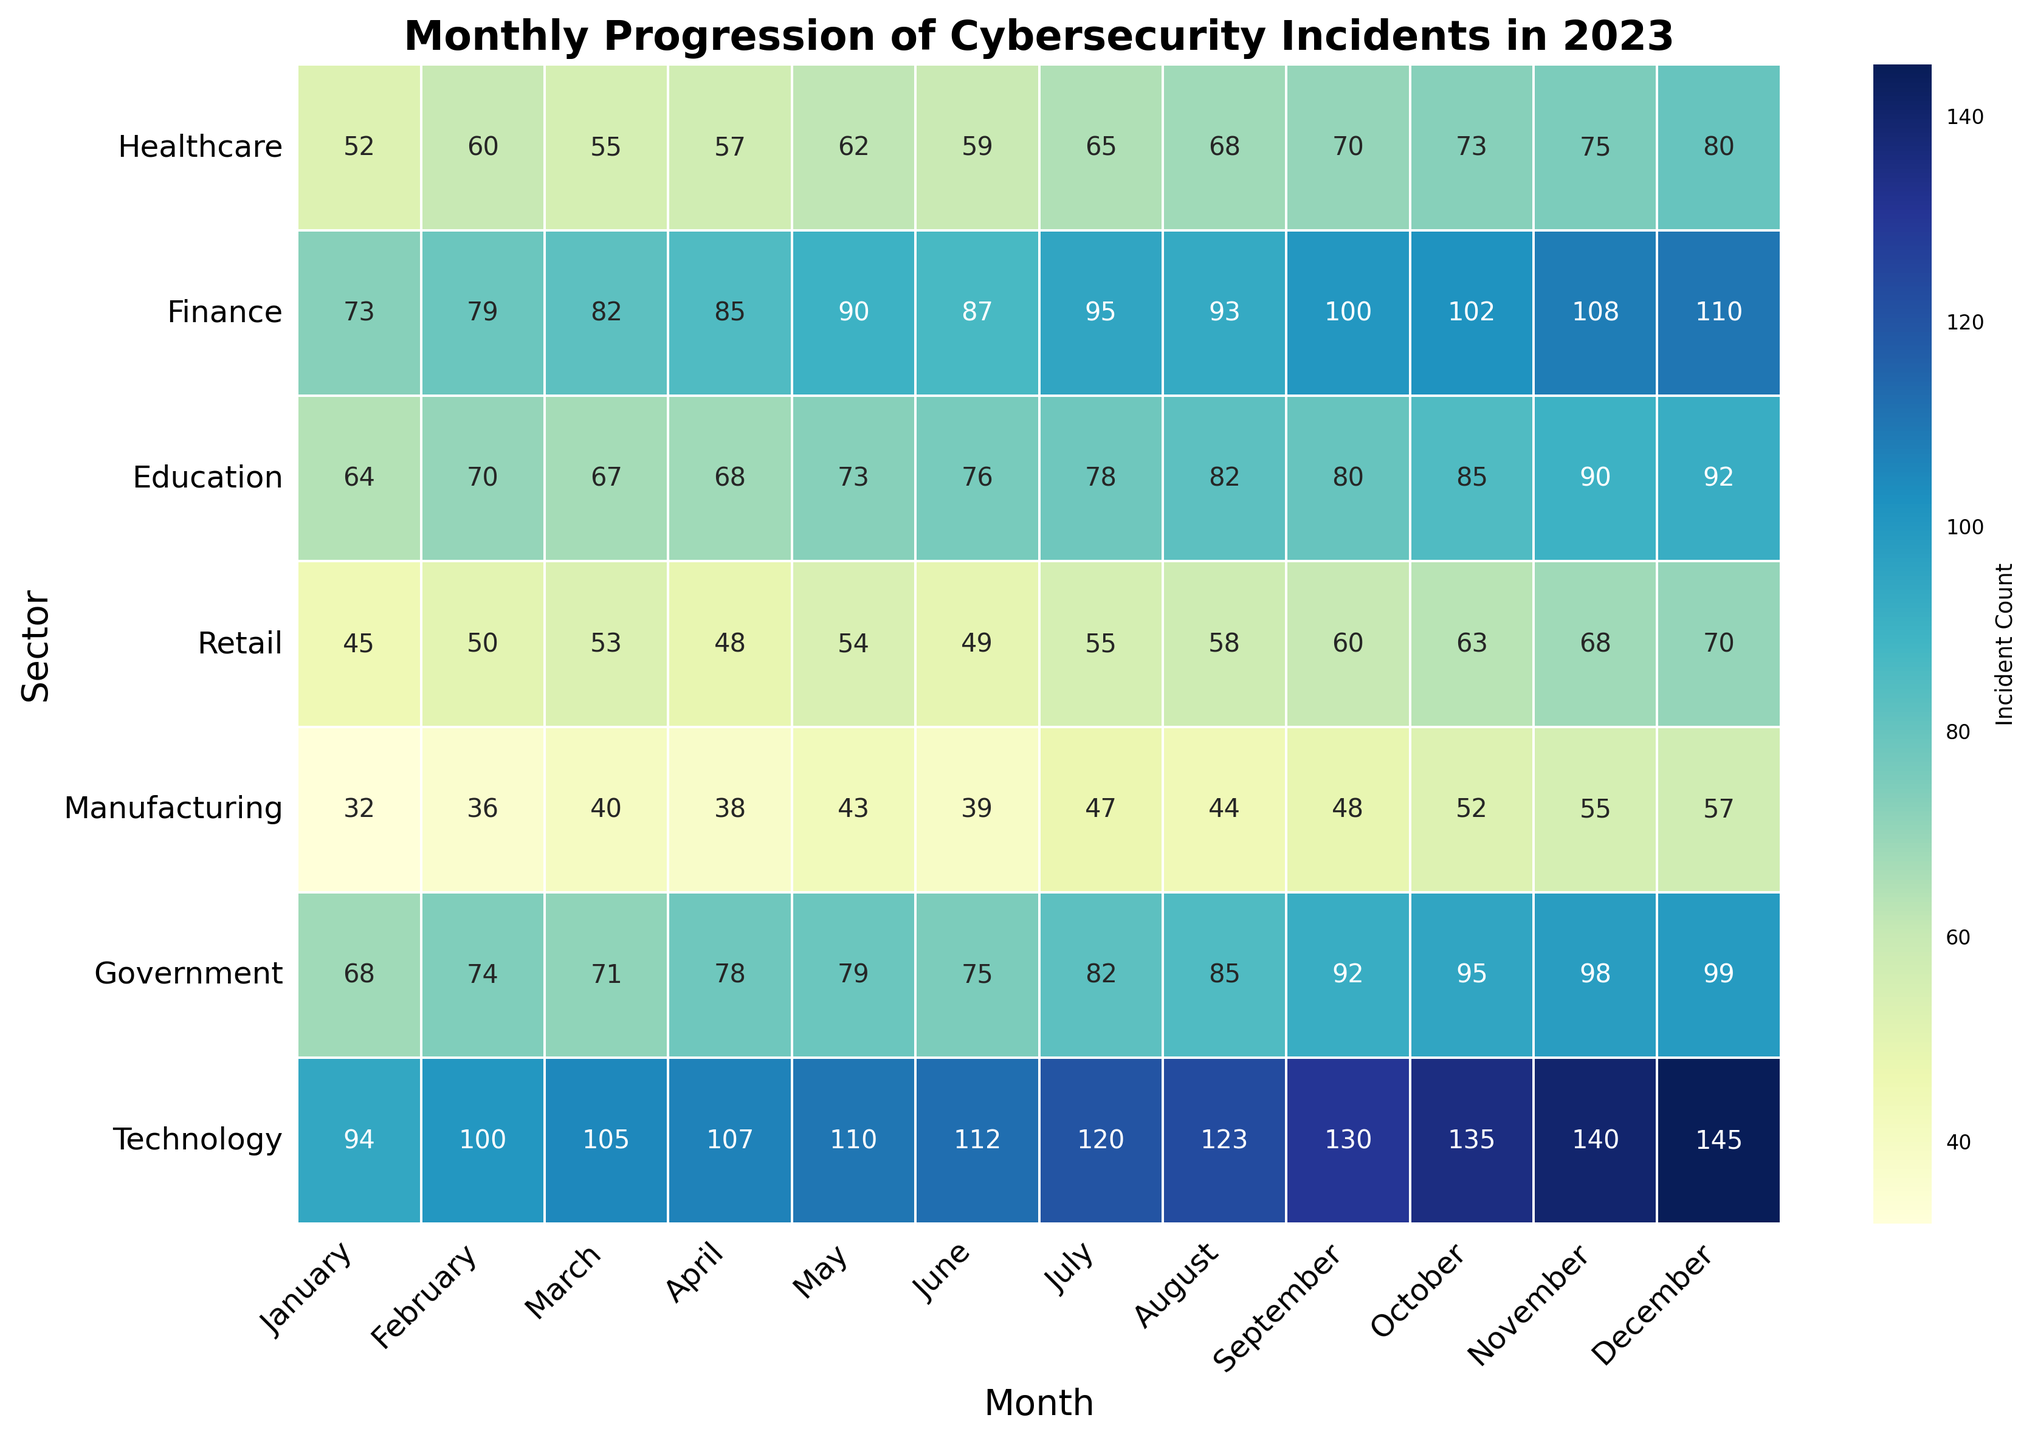Which sector experienced the highest number of cybersecurity incidents in December? By observing the heatmap, identify the sector with the darkest shade for December, indicating the highest number of incidents. The Technology sector shows the darkest shade.
Answer: Technology How many cybersecurity incidents in total did the Finance sector report in April and August combined? Locate the Finance row on the heatmap and find the values for April and August. April has 85 incidents, and August has 93 incidents. Summing them gives 85 + 93 = 178.
Answer: 178 Between Healthcare and Manufacturing, which sector experienced fewer incidents in October, and by how many incidents is it fewer? Compare the values in October for Healthcare and Manufacturing. Healthcare has 73 incidents, and Manufacturing has 52 incidents. The difference is 73 - 52 = 21.
Answer: Manufacturing, by 21 incidents Which month showed the greatest increase in cybersecurity incidents for the Technology sector compared to the previous month? Compare consecutive monthly values in the Technology row and identify the largest increase. The greatest increase is from August (123) to September (130), an increase of 130 - 123 = 7 incidents.
Answer: September Which two sectors showed exactly the same number of incidents in any month(s) during 2023? Scan through the heatmap to identify any matching values across different sectors for the same month. Healthcare and Manufacturing both reported 32 incidents in January.
Answer: Healthcare and Manufacturing in January What is the average number of cybersecurity incidents reported by the Government sector from January to June inclusive? Find the Government values from January to June: 68, 74, 71, 78, 79, 75. Sum these values, 68 + 74 + 71 + 78 + 79 + 75 = 445, and divide by the number of months (6). The average is 445 / 6 ≈ 74.17.
Answer: 74.17 Which sector showed the least variability in the number of monthly incidents throughout the year? Determine which sector's row values are most consistent (smallest range). Retail values range from 45 to 70, so its variability is less compared to other sectors. The Retail sector shows the least variability within 2023.
Answer: Retail Is there a month where every sector reported an increase in incidents compared to the previous month? Check each column (month) to see if all values are higher than the previous month's column. August compared to July shows an increase in every sector: Healthcare (65 to 68), Finance (95 to 93), Education (78 to 82), Retail (55 to 58), Manufacturing (47 to 44), Government (82 to 85), Technology (120 to 123).
Answer: August During which month did the Education sector report its maximum number of incidents, and what was the value? Locate the Education row and identify the highest value and corresponding month. The maximum value is 92 incidents in December.
Answer: December, 92 